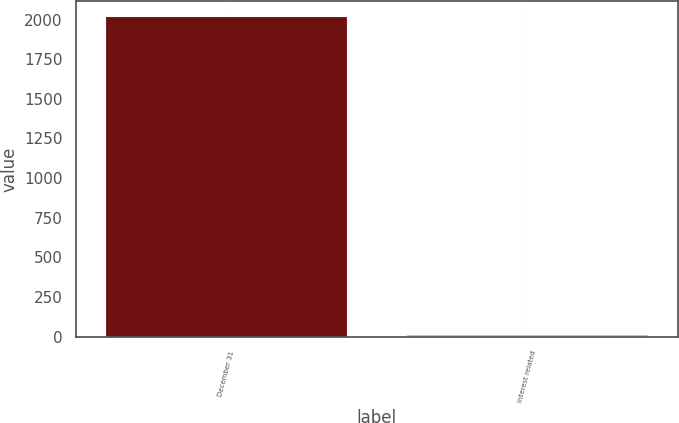Convert chart to OTSL. <chart><loc_0><loc_0><loc_500><loc_500><bar_chart><fcel>December 31<fcel>Interest related<nl><fcel>2015<fcel>8<nl></chart> 